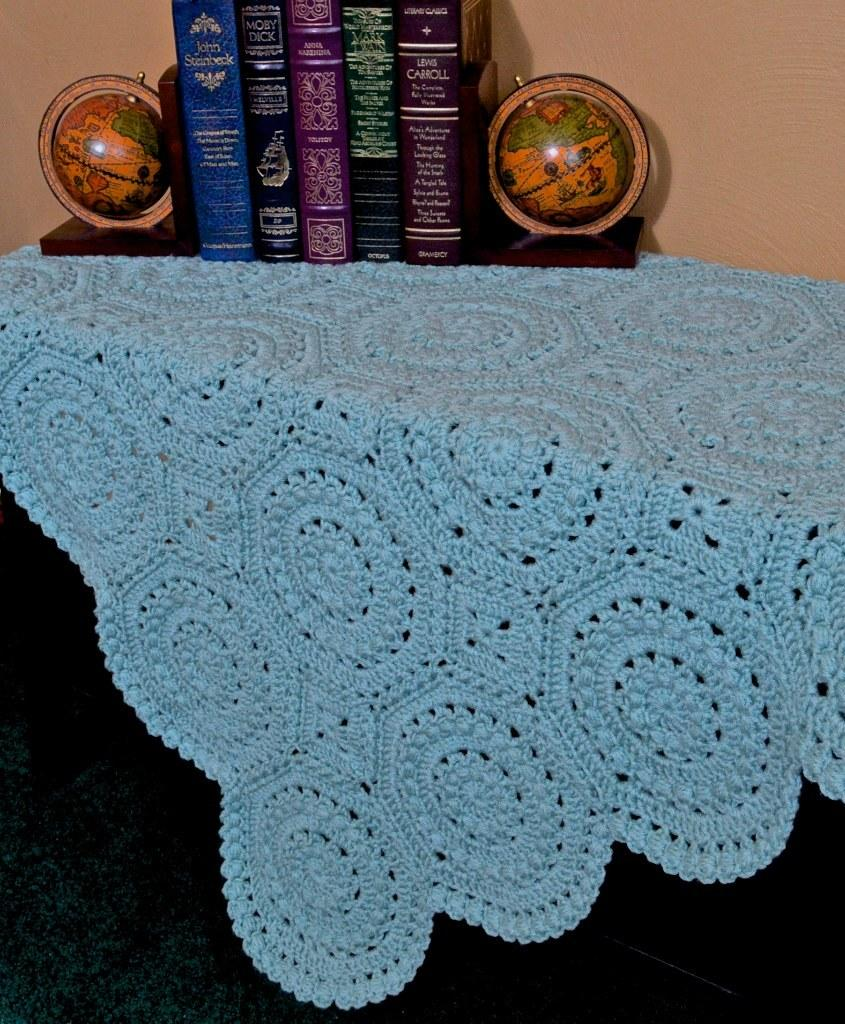<image>
Render a clear and concise summary of the photo. Two old-fashioned globe bookends on either side of books by John Steinbeck, Melville, and Lewis Carroll. 